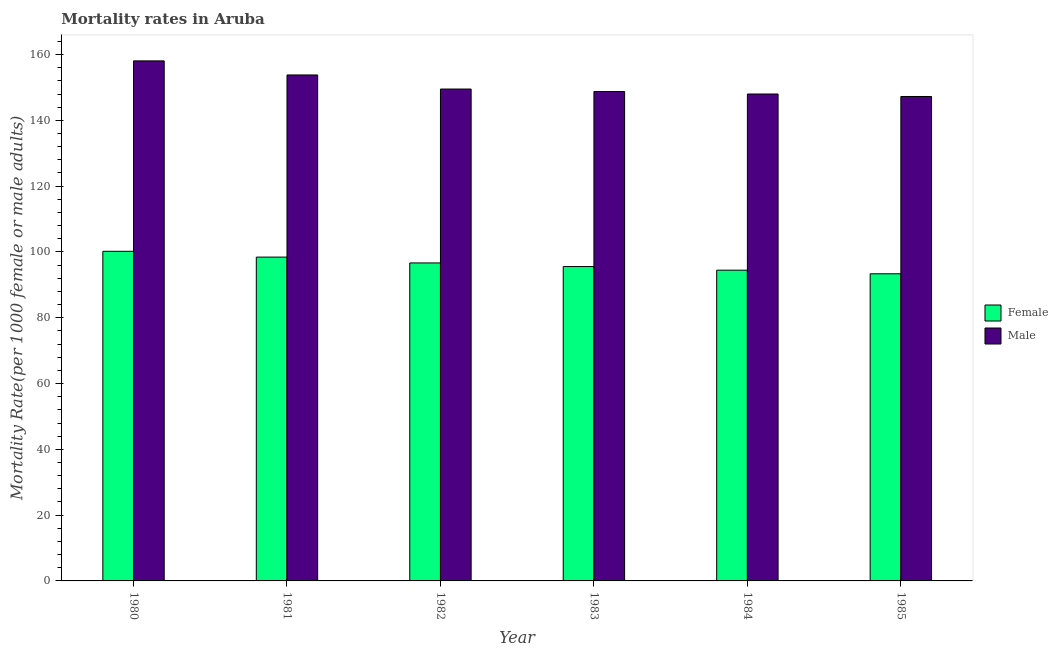How many groups of bars are there?
Provide a short and direct response. 6. Are the number of bars per tick equal to the number of legend labels?
Keep it short and to the point. Yes. Are the number of bars on each tick of the X-axis equal?
Give a very brief answer. Yes. How many bars are there on the 3rd tick from the right?
Make the answer very short. 2. In how many cases, is the number of bars for a given year not equal to the number of legend labels?
Make the answer very short. 0. What is the male mortality rate in 1983?
Offer a terse response. 148.76. Across all years, what is the maximum male mortality rate?
Provide a short and direct response. 158.07. Across all years, what is the minimum male mortality rate?
Provide a succinct answer. 147.25. In which year was the female mortality rate minimum?
Offer a terse response. 1985. What is the total male mortality rate in the graph?
Offer a very short reply. 905.4. What is the difference between the female mortality rate in 1983 and that in 1985?
Your answer should be compact. 2.2. What is the difference between the female mortality rate in 1981 and the male mortality rate in 1980?
Your answer should be very brief. -1.77. What is the average male mortality rate per year?
Offer a very short reply. 150.9. In the year 1983, what is the difference between the female mortality rate and male mortality rate?
Keep it short and to the point. 0. What is the ratio of the female mortality rate in 1980 to that in 1985?
Your answer should be very brief. 1.07. Is the male mortality rate in 1981 less than that in 1982?
Offer a terse response. No. What is the difference between the highest and the second highest male mortality rate?
Give a very brief answer. 4.28. What is the difference between the highest and the lowest female mortality rate?
Provide a succinct answer. 6.84. In how many years, is the female mortality rate greater than the average female mortality rate taken over all years?
Provide a succinct answer. 3. Are all the bars in the graph horizontal?
Ensure brevity in your answer.  No. How many years are there in the graph?
Keep it short and to the point. 6. Are the values on the major ticks of Y-axis written in scientific E-notation?
Ensure brevity in your answer.  No. Does the graph contain grids?
Give a very brief answer. No. Where does the legend appear in the graph?
Offer a very short reply. Center right. How many legend labels are there?
Give a very brief answer. 2. How are the legend labels stacked?
Give a very brief answer. Vertical. What is the title of the graph?
Offer a very short reply. Mortality rates in Aruba. Does "Age 65(male)" appear as one of the legend labels in the graph?
Offer a terse response. No. What is the label or title of the X-axis?
Offer a terse response. Year. What is the label or title of the Y-axis?
Your response must be concise. Mortality Rate(per 1000 female or male adults). What is the Mortality Rate(per 1000 female or male adults) in Female in 1980?
Ensure brevity in your answer.  100.2. What is the Mortality Rate(per 1000 female or male adults) in Male in 1980?
Make the answer very short. 158.07. What is the Mortality Rate(per 1000 female or male adults) in Female in 1981?
Offer a very short reply. 98.43. What is the Mortality Rate(per 1000 female or male adults) of Male in 1981?
Your answer should be compact. 153.79. What is the Mortality Rate(per 1000 female or male adults) of Female in 1982?
Provide a short and direct response. 96.66. What is the Mortality Rate(per 1000 female or male adults) of Male in 1982?
Make the answer very short. 149.51. What is the Mortality Rate(per 1000 female or male adults) of Female in 1983?
Give a very brief answer. 95.56. What is the Mortality Rate(per 1000 female or male adults) in Male in 1983?
Keep it short and to the point. 148.76. What is the Mortality Rate(per 1000 female or male adults) of Female in 1984?
Your response must be concise. 94.46. What is the Mortality Rate(per 1000 female or male adults) of Male in 1984?
Offer a terse response. 148. What is the Mortality Rate(per 1000 female or male adults) in Female in 1985?
Your response must be concise. 93.36. What is the Mortality Rate(per 1000 female or male adults) of Male in 1985?
Make the answer very short. 147.25. Across all years, what is the maximum Mortality Rate(per 1000 female or male adults) in Female?
Your response must be concise. 100.2. Across all years, what is the maximum Mortality Rate(per 1000 female or male adults) in Male?
Your response must be concise. 158.07. Across all years, what is the minimum Mortality Rate(per 1000 female or male adults) in Female?
Your response must be concise. 93.36. Across all years, what is the minimum Mortality Rate(per 1000 female or male adults) of Male?
Provide a succinct answer. 147.25. What is the total Mortality Rate(per 1000 female or male adults) of Female in the graph?
Offer a very short reply. 578.65. What is the total Mortality Rate(per 1000 female or male adults) in Male in the graph?
Your response must be concise. 905.4. What is the difference between the Mortality Rate(per 1000 female or male adults) in Female in 1980 and that in 1981?
Your answer should be very brief. 1.77. What is the difference between the Mortality Rate(per 1000 female or male adults) in Male in 1980 and that in 1981?
Ensure brevity in your answer.  4.28. What is the difference between the Mortality Rate(per 1000 female or male adults) of Female in 1980 and that in 1982?
Provide a short and direct response. 3.54. What is the difference between the Mortality Rate(per 1000 female or male adults) in Male in 1980 and that in 1982?
Offer a terse response. 8.56. What is the difference between the Mortality Rate(per 1000 female or male adults) of Female in 1980 and that in 1983?
Give a very brief answer. 4.64. What is the difference between the Mortality Rate(per 1000 female or male adults) of Male in 1980 and that in 1983?
Offer a terse response. 9.31. What is the difference between the Mortality Rate(per 1000 female or male adults) in Female in 1980 and that in 1984?
Your answer should be very brief. 5.74. What is the difference between the Mortality Rate(per 1000 female or male adults) in Male in 1980 and that in 1984?
Your answer should be very brief. 10.07. What is the difference between the Mortality Rate(per 1000 female or male adults) in Female in 1980 and that in 1985?
Provide a succinct answer. 6.84. What is the difference between the Mortality Rate(per 1000 female or male adults) of Male in 1980 and that in 1985?
Ensure brevity in your answer.  10.82. What is the difference between the Mortality Rate(per 1000 female or male adults) in Female in 1981 and that in 1982?
Provide a succinct answer. 1.77. What is the difference between the Mortality Rate(per 1000 female or male adults) of Male in 1981 and that in 1982?
Keep it short and to the point. 4.28. What is the difference between the Mortality Rate(per 1000 female or male adults) of Female in 1981 and that in 1983?
Provide a succinct answer. 2.87. What is the difference between the Mortality Rate(per 1000 female or male adults) in Male in 1981 and that in 1983?
Offer a very short reply. 5.03. What is the difference between the Mortality Rate(per 1000 female or male adults) of Female in 1981 and that in 1984?
Offer a terse response. 3.97. What is the difference between the Mortality Rate(per 1000 female or male adults) of Male in 1981 and that in 1984?
Your answer should be compact. 5.79. What is the difference between the Mortality Rate(per 1000 female or male adults) of Female in 1981 and that in 1985?
Keep it short and to the point. 5.07. What is the difference between the Mortality Rate(per 1000 female or male adults) in Male in 1981 and that in 1985?
Your answer should be compact. 6.54. What is the difference between the Mortality Rate(per 1000 female or male adults) of Female in 1982 and that in 1983?
Offer a very short reply. 1.1. What is the difference between the Mortality Rate(per 1000 female or male adults) of Male in 1982 and that in 1983?
Give a very brief answer. 0.75. What is the difference between the Mortality Rate(per 1000 female or male adults) in Female in 1982 and that in 1984?
Ensure brevity in your answer.  2.2. What is the difference between the Mortality Rate(per 1000 female or male adults) in Male in 1982 and that in 1984?
Offer a terse response. 1.51. What is the difference between the Mortality Rate(per 1000 female or male adults) of Female in 1982 and that in 1985?
Provide a short and direct response. 3.3. What is the difference between the Mortality Rate(per 1000 female or male adults) in Male in 1982 and that in 1985?
Ensure brevity in your answer.  2.26. What is the difference between the Mortality Rate(per 1000 female or male adults) of Male in 1983 and that in 1984?
Offer a terse response. 0.76. What is the difference between the Mortality Rate(per 1000 female or male adults) of Female in 1983 and that in 1985?
Your response must be concise. 2.2. What is the difference between the Mortality Rate(per 1000 female or male adults) in Male in 1983 and that in 1985?
Your response must be concise. 1.51. What is the difference between the Mortality Rate(per 1000 female or male adults) in Female in 1984 and that in 1985?
Keep it short and to the point. 1.1. What is the difference between the Mortality Rate(per 1000 female or male adults) of Male in 1984 and that in 1985?
Your answer should be very brief. 0.76. What is the difference between the Mortality Rate(per 1000 female or male adults) in Female in 1980 and the Mortality Rate(per 1000 female or male adults) in Male in 1981?
Offer a very short reply. -53.6. What is the difference between the Mortality Rate(per 1000 female or male adults) in Female in 1980 and the Mortality Rate(per 1000 female or male adults) in Male in 1982?
Your answer should be compact. -49.32. What is the difference between the Mortality Rate(per 1000 female or male adults) in Female in 1980 and the Mortality Rate(per 1000 female or male adults) in Male in 1983?
Provide a succinct answer. -48.56. What is the difference between the Mortality Rate(per 1000 female or male adults) of Female in 1980 and the Mortality Rate(per 1000 female or male adults) of Male in 1984?
Your answer should be very brief. -47.81. What is the difference between the Mortality Rate(per 1000 female or male adults) of Female in 1980 and the Mortality Rate(per 1000 female or male adults) of Male in 1985?
Give a very brief answer. -47.05. What is the difference between the Mortality Rate(per 1000 female or male adults) of Female in 1981 and the Mortality Rate(per 1000 female or male adults) of Male in 1982?
Your answer should be very brief. -51.09. What is the difference between the Mortality Rate(per 1000 female or male adults) of Female in 1981 and the Mortality Rate(per 1000 female or male adults) of Male in 1983?
Provide a succinct answer. -50.33. What is the difference between the Mortality Rate(per 1000 female or male adults) of Female in 1981 and the Mortality Rate(per 1000 female or male adults) of Male in 1984?
Your answer should be compact. -49.58. What is the difference between the Mortality Rate(per 1000 female or male adults) of Female in 1981 and the Mortality Rate(per 1000 female or male adults) of Male in 1985?
Give a very brief answer. -48.82. What is the difference between the Mortality Rate(per 1000 female or male adults) of Female in 1982 and the Mortality Rate(per 1000 female or male adults) of Male in 1983?
Offer a terse response. -52.1. What is the difference between the Mortality Rate(per 1000 female or male adults) of Female in 1982 and the Mortality Rate(per 1000 female or male adults) of Male in 1984?
Ensure brevity in your answer.  -51.35. What is the difference between the Mortality Rate(per 1000 female or male adults) in Female in 1982 and the Mortality Rate(per 1000 female or male adults) in Male in 1985?
Keep it short and to the point. -50.59. What is the difference between the Mortality Rate(per 1000 female or male adults) of Female in 1983 and the Mortality Rate(per 1000 female or male adults) of Male in 1984?
Make the answer very short. -52.45. What is the difference between the Mortality Rate(per 1000 female or male adults) of Female in 1983 and the Mortality Rate(per 1000 female or male adults) of Male in 1985?
Give a very brief answer. -51.69. What is the difference between the Mortality Rate(per 1000 female or male adults) of Female in 1984 and the Mortality Rate(per 1000 female or male adults) of Male in 1985?
Offer a very short reply. -52.79. What is the average Mortality Rate(per 1000 female or male adults) of Female per year?
Provide a succinct answer. 96.44. What is the average Mortality Rate(per 1000 female or male adults) of Male per year?
Make the answer very short. 150.9. In the year 1980, what is the difference between the Mortality Rate(per 1000 female or male adults) of Female and Mortality Rate(per 1000 female or male adults) of Male?
Make the answer very short. -57.88. In the year 1981, what is the difference between the Mortality Rate(per 1000 female or male adults) in Female and Mortality Rate(per 1000 female or male adults) in Male?
Keep it short and to the point. -55.37. In the year 1982, what is the difference between the Mortality Rate(per 1000 female or male adults) in Female and Mortality Rate(per 1000 female or male adults) in Male?
Your response must be concise. -52.86. In the year 1983, what is the difference between the Mortality Rate(per 1000 female or male adults) in Female and Mortality Rate(per 1000 female or male adults) in Male?
Your answer should be compact. -53.2. In the year 1984, what is the difference between the Mortality Rate(per 1000 female or male adults) in Female and Mortality Rate(per 1000 female or male adults) in Male?
Provide a short and direct response. -53.55. In the year 1985, what is the difference between the Mortality Rate(per 1000 female or male adults) of Female and Mortality Rate(per 1000 female or male adults) of Male?
Your answer should be compact. -53.9. What is the ratio of the Mortality Rate(per 1000 female or male adults) in Female in 1980 to that in 1981?
Provide a short and direct response. 1.02. What is the ratio of the Mortality Rate(per 1000 female or male adults) in Male in 1980 to that in 1981?
Make the answer very short. 1.03. What is the ratio of the Mortality Rate(per 1000 female or male adults) of Female in 1980 to that in 1982?
Provide a succinct answer. 1.04. What is the ratio of the Mortality Rate(per 1000 female or male adults) of Male in 1980 to that in 1982?
Make the answer very short. 1.06. What is the ratio of the Mortality Rate(per 1000 female or male adults) of Female in 1980 to that in 1983?
Ensure brevity in your answer.  1.05. What is the ratio of the Mortality Rate(per 1000 female or male adults) in Male in 1980 to that in 1983?
Keep it short and to the point. 1.06. What is the ratio of the Mortality Rate(per 1000 female or male adults) in Female in 1980 to that in 1984?
Provide a short and direct response. 1.06. What is the ratio of the Mortality Rate(per 1000 female or male adults) in Male in 1980 to that in 1984?
Provide a short and direct response. 1.07. What is the ratio of the Mortality Rate(per 1000 female or male adults) in Female in 1980 to that in 1985?
Provide a short and direct response. 1.07. What is the ratio of the Mortality Rate(per 1000 female or male adults) in Male in 1980 to that in 1985?
Make the answer very short. 1.07. What is the ratio of the Mortality Rate(per 1000 female or male adults) of Female in 1981 to that in 1982?
Your answer should be very brief. 1.02. What is the ratio of the Mortality Rate(per 1000 female or male adults) of Male in 1981 to that in 1982?
Provide a short and direct response. 1.03. What is the ratio of the Mortality Rate(per 1000 female or male adults) in Female in 1981 to that in 1983?
Offer a very short reply. 1.03. What is the ratio of the Mortality Rate(per 1000 female or male adults) in Male in 1981 to that in 1983?
Your answer should be very brief. 1.03. What is the ratio of the Mortality Rate(per 1000 female or male adults) of Female in 1981 to that in 1984?
Your answer should be very brief. 1.04. What is the ratio of the Mortality Rate(per 1000 female or male adults) in Male in 1981 to that in 1984?
Keep it short and to the point. 1.04. What is the ratio of the Mortality Rate(per 1000 female or male adults) of Female in 1981 to that in 1985?
Ensure brevity in your answer.  1.05. What is the ratio of the Mortality Rate(per 1000 female or male adults) of Male in 1981 to that in 1985?
Offer a terse response. 1.04. What is the ratio of the Mortality Rate(per 1000 female or male adults) of Female in 1982 to that in 1983?
Make the answer very short. 1.01. What is the ratio of the Mortality Rate(per 1000 female or male adults) of Male in 1982 to that in 1983?
Offer a very short reply. 1.01. What is the ratio of the Mortality Rate(per 1000 female or male adults) in Female in 1982 to that in 1984?
Keep it short and to the point. 1.02. What is the ratio of the Mortality Rate(per 1000 female or male adults) in Male in 1982 to that in 1984?
Provide a succinct answer. 1.01. What is the ratio of the Mortality Rate(per 1000 female or male adults) of Female in 1982 to that in 1985?
Provide a short and direct response. 1.04. What is the ratio of the Mortality Rate(per 1000 female or male adults) of Male in 1982 to that in 1985?
Ensure brevity in your answer.  1.02. What is the ratio of the Mortality Rate(per 1000 female or male adults) of Female in 1983 to that in 1984?
Offer a very short reply. 1.01. What is the ratio of the Mortality Rate(per 1000 female or male adults) of Male in 1983 to that in 1984?
Keep it short and to the point. 1.01. What is the ratio of the Mortality Rate(per 1000 female or male adults) of Female in 1983 to that in 1985?
Your response must be concise. 1.02. What is the ratio of the Mortality Rate(per 1000 female or male adults) in Male in 1983 to that in 1985?
Give a very brief answer. 1.01. What is the ratio of the Mortality Rate(per 1000 female or male adults) of Female in 1984 to that in 1985?
Provide a short and direct response. 1.01. What is the difference between the highest and the second highest Mortality Rate(per 1000 female or male adults) in Female?
Make the answer very short. 1.77. What is the difference between the highest and the second highest Mortality Rate(per 1000 female or male adults) of Male?
Offer a terse response. 4.28. What is the difference between the highest and the lowest Mortality Rate(per 1000 female or male adults) of Female?
Offer a terse response. 6.84. What is the difference between the highest and the lowest Mortality Rate(per 1000 female or male adults) of Male?
Provide a short and direct response. 10.82. 